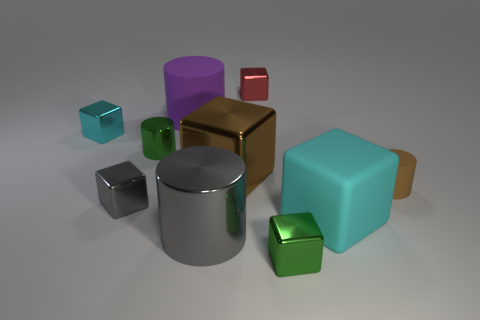Do the red shiny object and the tiny green shiny object that is to the right of the big purple rubber object have the same shape?
Your answer should be compact. Yes. What is the shape of the shiny thing that is the same color as the big shiny cylinder?
Provide a short and direct response. Cube. Is the number of small gray things that are on the right side of the tiny green metallic cube less than the number of small blue metal objects?
Keep it short and to the point. No. Do the cyan rubber object and the small red metallic object have the same shape?
Your response must be concise. Yes. There is a brown object that is made of the same material as the purple thing; what is its size?
Ensure brevity in your answer.  Small. Is the number of large cyan balls less than the number of small green metal objects?
Your answer should be very brief. Yes. How many large things are rubber cylinders or cylinders?
Provide a short and direct response. 2. How many small things are in front of the big metallic cylinder and on the left side of the small green cube?
Make the answer very short. 0. Are there more large cyan metal balls than big cyan blocks?
Make the answer very short. No. How many other objects are the same shape as the tiny brown object?
Provide a short and direct response. 3. 